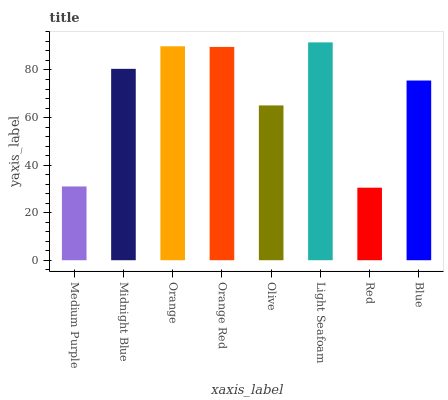Is Red the minimum?
Answer yes or no. Yes. Is Light Seafoam the maximum?
Answer yes or no. Yes. Is Midnight Blue the minimum?
Answer yes or no. No. Is Midnight Blue the maximum?
Answer yes or no. No. Is Midnight Blue greater than Medium Purple?
Answer yes or no. Yes. Is Medium Purple less than Midnight Blue?
Answer yes or no. Yes. Is Medium Purple greater than Midnight Blue?
Answer yes or no. No. Is Midnight Blue less than Medium Purple?
Answer yes or no. No. Is Midnight Blue the high median?
Answer yes or no. Yes. Is Blue the low median?
Answer yes or no. Yes. Is Light Seafoam the high median?
Answer yes or no. No. Is Light Seafoam the low median?
Answer yes or no. No. 